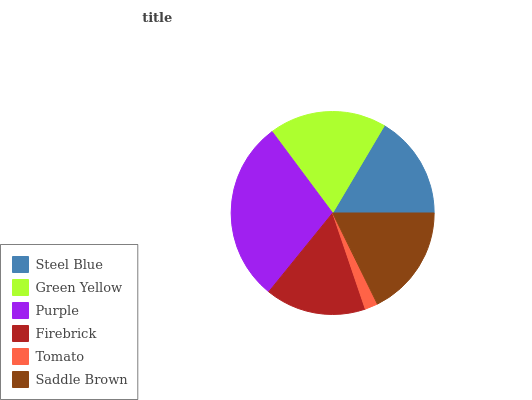Is Tomato the minimum?
Answer yes or no. Yes. Is Purple the maximum?
Answer yes or no. Yes. Is Green Yellow the minimum?
Answer yes or no. No. Is Green Yellow the maximum?
Answer yes or no. No. Is Green Yellow greater than Steel Blue?
Answer yes or no. Yes. Is Steel Blue less than Green Yellow?
Answer yes or no. Yes. Is Steel Blue greater than Green Yellow?
Answer yes or no. No. Is Green Yellow less than Steel Blue?
Answer yes or no. No. Is Saddle Brown the high median?
Answer yes or no. Yes. Is Steel Blue the low median?
Answer yes or no. Yes. Is Green Yellow the high median?
Answer yes or no. No. Is Purple the low median?
Answer yes or no. No. 